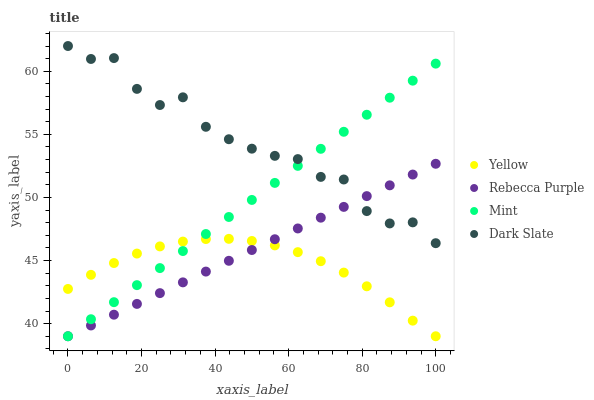Does Yellow have the minimum area under the curve?
Answer yes or no. Yes. Does Dark Slate have the maximum area under the curve?
Answer yes or no. Yes. Does Mint have the minimum area under the curve?
Answer yes or no. No. Does Mint have the maximum area under the curve?
Answer yes or no. No. Is Rebecca Purple the smoothest?
Answer yes or no. Yes. Is Dark Slate the roughest?
Answer yes or no. Yes. Is Mint the smoothest?
Answer yes or no. No. Is Mint the roughest?
Answer yes or no. No. Does Mint have the lowest value?
Answer yes or no. Yes. Does Dark Slate have the highest value?
Answer yes or no. Yes. Does Mint have the highest value?
Answer yes or no. No. Is Yellow less than Dark Slate?
Answer yes or no. Yes. Is Dark Slate greater than Yellow?
Answer yes or no. Yes. Does Yellow intersect Mint?
Answer yes or no. Yes. Is Yellow less than Mint?
Answer yes or no. No. Is Yellow greater than Mint?
Answer yes or no. No. Does Yellow intersect Dark Slate?
Answer yes or no. No. 